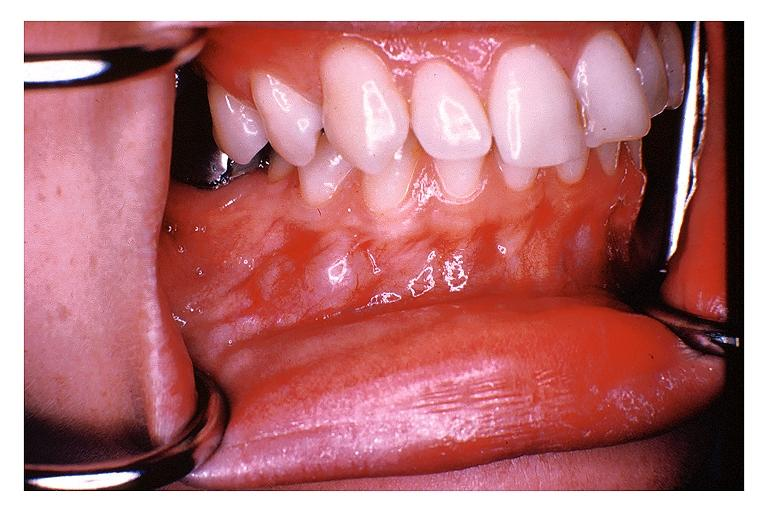where is this?
Answer the question using a single word or phrase. Oral 